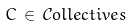Convert formula to latex. <formula><loc_0><loc_0><loc_500><loc_500>C \, \in \, { \mathcal { C } } o l l e c t i v e s</formula> 